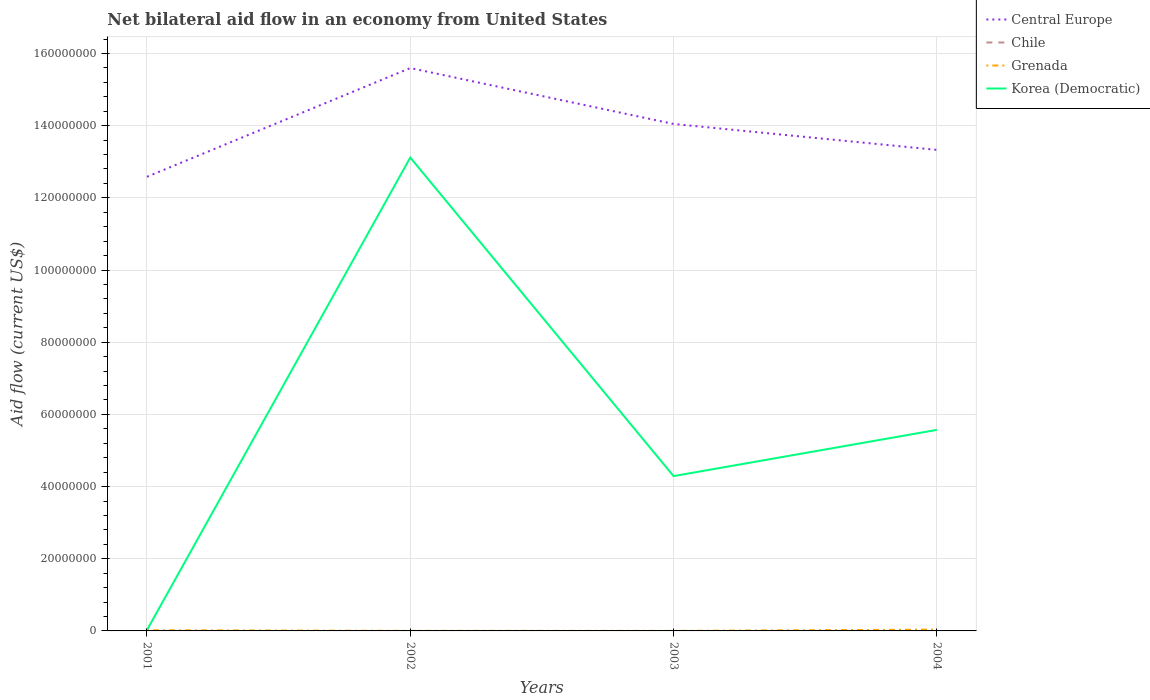How many different coloured lines are there?
Provide a succinct answer. 3. Is the number of lines equal to the number of legend labels?
Your answer should be very brief. No. Across all years, what is the maximum net bilateral aid flow in Central Europe?
Provide a short and direct response. 1.26e+08. What is the total net bilateral aid flow in Central Europe in the graph?
Your response must be concise. -7.45e+06. What is the difference between the highest and the second highest net bilateral aid flow in Korea (Democratic)?
Offer a terse response. 1.31e+08. What is the difference between the highest and the lowest net bilateral aid flow in Chile?
Offer a terse response. 0. Are the values on the major ticks of Y-axis written in scientific E-notation?
Make the answer very short. No. Does the graph contain grids?
Keep it short and to the point. Yes. How many legend labels are there?
Give a very brief answer. 4. How are the legend labels stacked?
Give a very brief answer. Vertical. What is the title of the graph?
Provide a succinct answer. Net bilateral aid flow in an economy from United States. What is the label or title of the X-axis?
Your answer should be very brief. Years. What is the label or title of the Y-axis?
Provide a succinct answer. Aid flow (current US$). What is the Aid flow (current US$) in Central Europe in 2001?
Provide a short and direct response. 1.26e+08. What is the Aid flow (current US$) of Central Europe in 2002?
Your response must be concise. 1.56e+08. What is the Aid flow (current US$) of Chile in 2002?
Provide a short and direct response. 0. What is the Aid flow (current US$) of Korea (Democratic) in 2002?
Offer a very short reply. 1.31e+08. What is the Aid flow (current US$) of Central Europe in 2003?
Offer a very short reply. 1.40e+08. What is the Aid flow (current US$) of Chile in 2003?
Your answer should be very brief. 0. What is the Aid flow (current US$) of Grenada in 2003?
Offer a very short reply. 10000. What is the Aid flow (current US$) in Korea (Democratic) in 2003?
Provide a short and direct response. 4.29e+07. What is the Aid flow (current US$) in Central Europe in 2004?
Your answer should be compact. 1.33e+08. What is the Aid flow (current US$) of Korea (Democratic) in 2004?
Provide a short and direct response. 5.57e+07. Across all years, what is the maximum Aid flow (current US$) in Central Europe?
Your response must be concise. 1.56e+08. Across all years, what is the maximum Aid flow (current US$) of Grenada?
Your answer should be very brief. 3.70e+05. Across all years, what is the maximum Aid flow (current US$) in Korea (Democratic)?
Provide a succinct answer. 1.31e+08. Across all years, what is the minimum Aid flow (current US$) in Central Europe?
Keep it short and to the point. 1.26e+08. Across all years, what is the minimum Aid flow (current US$) of Grenada?
Offer a terse response. 10000. What is the total Aid flow (current US$) of Central Europe in the graph?
Your answer should be very brief. 5.56e+08. What is the total Aid flow (current US$) in Chile in the graph?
Offer a terse response. 0. What is the total Aid flow (current US$) in Grenada in the graph?
Keep it short and to the point. 5.90e+05. What is the total Aid flow (current US$) in Korea (Democratic) in the graph?
Ensure brevity in your answer.  2.30e+08. What is the difference between the Aid flow (current US$) of Central Europe in 2001 and that in 2002?
Keep it short and to the point. -3.01e+07. What is the difference between the Aid flow (current US$) in Korea (Democratic) in 2001 and that in 2002?
Provide a succinct answer. -1.31e+08. What is the difference between the Aid flow (current US$) in Central Europe in 2001 and that in 2003?
Keep it short and to the point. -1.46e+07. What is the difference between the Aid flow (current US$) in Korea (Democratic) in 2001 and that in 2003?
Give a very brief answer. -4.26e+07. What is the difference between the Aid flow (current US$) in Central Europe in 2001 and that in 2004?
Provide a succinct answer. -7.45e+06. What is the difference between the Aid flow (current US$) of Grenada in 2001 and that in 2004?
Offer a very short reply. -1.80e+05. What is the difference between the Aid flow (current US$) in Korea (Democratic) in 2001 and that in 2004?
Your answer should be compact. -5.55e+07. What is the difference between the Aid flow (current US$) of Central Europe in 2002 and that in 2003?
Make the answer very short. 1.55e+07. What is the difference between the Aid flow (current US$) in Grenada in 2002 and that in 2003?
Your response must be concise. 10000. What is the difference between the Aid flow (current US$) in Korea (Democratic) in 2002 and that in 2003?
Give a very brief answer. 8.83e+07. What is the difference between the Aid flow (current US$) in Central Europe in 2002 and that in 2004?
Offer a terse response. 2.27e+07. What is the difference between the Aid flow (current US$) of Grenada in 2002 and that in 2004?
Offer a very short reply. -3.50e+05. What is the difference between the Aid flow (current US$) of Korea (Democratic) in 2002 and that in 2004?
Offer a terse response. 7.55e+07. What is the difference between the Aid flow (current US$) of Central Europe in 2003 and that in 2004?
Keep it short and to the point. 7.19e+06. What is the difference between the Aid flow (current US$) of Grenada in 2003 and that in 2004?
Keep it short and to the point. -3.60e+05. What is the difference between the Aid flow (current US$) of Korea (Democratic) in 2003 and that in 2004?
Provide a short and direct response. -1.28e+07. What is the difference between the Aid flow (current US$) of Central Europe in 2001 and the Aid flow (current US$) of Grenada in 2002?
Your answer should be compact. 1.26e+08. What is the difference between the Aid flow (current US$) in Central Europe in 2001 and the Aid flow (current US$) in Korea (Democratic) in 2002?
Your response must be concise. -5.33e+06. What is the difference between the Aid flow (current US$) in Grenada in 2001 and the Aid flow (current US$) in Korea (Democratic) in 2002?
Keep it short and to the point. -1.31e+08. What is the difference between the Aid flow (current US$) in Central Europe in 2001 and the Aid flow (current US$) in Grenada in 2003?
Provide a short and direct response. 1.26e+08. What is the difference between the Aid flow (current US$) of Central Europe in 2001 and the Aid flow (current US$) of Korea (Democratic) in 2003?
Give a very brief answer. 8.29e+07. What is the difference between the Aid flow (current US$) of Grenada in 2001 and the Aid flow (current US$) of Korea (Democratic) in 2003?
Ensure brevity in your answer.  -4.27e+07. What is the difference between the Aid flow (current US$) of Central Europe in 2001 and the Aid flow (current US$) of Grenada in 2004?
Keep it short and to the point. 1.25e+08. What is the difference between the Aid flow (current US$) of Central Europe in 2001 and the Aid flow (current US$) of Korea (Democratic) in 2004?
Provide a succinct answer. 7.01e+07. What is the difference between the Aid flow (current US$) in Grenada in 2001 and the Aid flow (current US$) in Korea (Democratic) in 2004?
Your answer should be compact. -5.55e+07. What is the difference between the Aid flow (current US$) in Central Europe in 2002 and the Aid flow (current US$) in Grenada in 2003?
Offer a terse response. 1.56e+08. What is the difference between the Aid flow (current US$) in Central Europe in 2002 and the Aid flow (current US$) in Korea (Democratic) in 2003?
Offer a very short reply. 1.13e+08. What is the difference between the Aid flow (current US$) in Grenada in 2002 and the Aid flow (current US$) in Korea (Democratic) in 2003?
Your answer should be very brief. -4.29e+07. What is the difference between the Aid flow (current US$) of Central Europe in 2002 and the Aid flow (current US$) of Grenada in 2004?
Keep it short and to the point. 1.56e+08. What is the difference between the Aid flow (current US$) of Central Europe in 2002 and the Aid flow (current US$) of Korea (Democratic) in 2004?
Give a very brief answer. 1.00e+08. What is the difference between the Aid flow (current US$) of Grenada in 2002 and the Aid flow (current US$) of Korea (Democratic) in 2004?
Offer a very short reply. -5.57e+07. What is the difference between the Aid flow (current US$) in Central Europe in 2003 and the Aid flow (current US$) in Grenada in 2004?
Offer a terse response. 1.40e+08. What is the difference between the Aid flow (current US$) of Central Europe in 2003 and the Aid flow (current US$) of Korea (Democratic) in 2004?
Provide a succinct answer. 8.48e+07. What is the difference between the Aid flow (current US$) of Grenada in 2003 and the Aid flow (current US$) of Korea (Democratic) in 2004?
Your answer should be compact. -5.57e+07. What is the average Aid flow (current US$) in Central Europe per year?
Your answer should be compact. 1.39e+08. What is the average Aid flow (current US$) in Grenada per year?
Make the answer very short. 1.48e+05. What is the average Aid flow (current US$) of Korea (Democratic) per year?
Offer a very short reply. 5.75e+07. In the year 2001, what is the difference between the Aid flow (current US$) in Central Europe and Aid flow (current US$) in Grenada?
Offer a terse response. 1.26e+08. In the year 2001, what is the difference between the Aid flow (current US$) in Central Europe and Aid flow (current US$) in Korea (Democratic)?
Your answer should be very brief. 1.26e+08. In the year 2002, what is the difference between the Aid flow (current US$) in Central Europe and Aid flow (current US$) in Grenada?
Provide a succinct answer. 1.56e+08. In the year 2002, what is the difference between the Aid flow (current US$) of Central Europe and Aid flow (current US$) of Korea (Democratic)?
Give a very brief answer. 2.48e+07. In the year 2002, what is the difference between the Aid flow (current US$) of Grenada and Aid flow (current US$) of Korea (Democratic)?
Provide a succinct answer. -1.31e+08. In the year 2003, what is the difference between the Aid flow (current US$) in Central Europe and Aid flow (current US$) in Grenada?
Keep it short and to the point. 1.40e+08. In the year 2003, what is the difference between the Aid flow (current US$) in Central Europe and Aid flow (current US$) in Korea (Democratic)?
Offer a very short reply. 9.76e+07. In the year 2003, what is the difference between the Aid flow (current US$) in Grenada and Aid flow (current US$) in Korea (Democratic)?
Keep it short and to the point. -4.29e+07. In the year 2004, what is the difference between the Aid flow (current US$) in Central Europe and Aid flow (current US$) in Grenada?
Make the answer very short. 1.33e+08. In the year 2004, what is the difference between the Aid flow (current US$) of Central Europe and Aid flow (current US$) of Korea (Democratic)?
Ensure brevity in your answer.  7.76e+07. In the year 2004, what is the difference between the Aid flow (current US$) of Grenada and Aid flow (current US$) of Korea (Democratic)?
Ensure brevity in your answer.  -5.53e+07. What is the ratio of the Aid flow (current US$) of Central Europe in 2001 to that in 2002?
Keep it short and to the point. 0.81. What is the ratio of the Aid flow (current US$) in Korea (Democratic) in 2001 to that in 2002?
Provide a short and direct response. 0. What is the ratio of the Aid flow (current US$) in Central Europe in 2001 to that in 2003?
Your answer should be very brief. 0.9. What is the ratio of the Aid flow (current US$) in Korea (Democratic) in 2001 to that in 2003?
Make the answer very short. 0.01. What is the ratio of the Aid flow (current US$) of Central Europe in 2001 to that in 2004?
Keep it short and to the point. 0.94. What is the ratio of the Aid flow (current US$) in Grenada in 2001 to that in 2004?
Offer a terse response. 0.51. What is the ratio of the Aid flow (current US$) of Korea (Democratic) in 2001 to that in 2004?
Your answer should be very brief. 0. What is the ratio of the Aid flow (current US$) of Central Europe in 2002 to that in 2003?
Your answer should be compact. 1.11. What is the ratio of the Aid flow (current US$) in Grenada in 2002 to that in 2003?
Your answer should be compact. 2. What is the ratio of the Aid flow (current US$) of Korea (Democratic) in 2002 to that in 2003?
Offer a terse response. 3.06. What is the ratio of the Aid flow (current US$) of Central Europe in 2002 to that in 2004?
Provide a succinct answer. 1.17. What is the ratio of the Aid flow (current US$) in Grenada in 2002 to that in 2004?
Your answer should be very brief. 0.05. What is the ratio of the Aid flow (current US$) in Korea (Democratic) in 2002 to that in 2004?
Offer a terse response. 2.35. What is the ratio of the Aid flow (current US$) in Central Europe in 2003 to that in 2004?
Ensure brevity in your answer.  1.05. What is the ratio of the Aid flow (current US$) of Grenada in 2003 to that in 2004?
Keep it short and to the point. 0.03. What is the ratio of the Aid flow (current US$) of Korea (Democratic) in 2003 to that in 2004?
Your answer should be very brief. 0.77. What is the difference between the highest and the second highest Aid flow (current US$) in Central Europe?
Give a very brief answer. 1.55e+07. What is the difference between the highest and the second highest Aid flow (current US$) in Korea (Democratic)?
Offer a very short reply. 7.55e+07. What is the difference between the highest and the lowest Aid flow (current US$) of Central Europe?
Your response must be concise. 3.01e+07. What is the difference between the highest and the lowest Aid flow (current US$) of Korea (Democratic)?
Offer a terse response. 1.31e+08. 